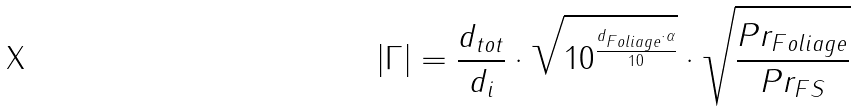Convert formula to latex. <formula><loc_0><loc_0><loc_500><loc_500>| \Gamma | = \frac { d _ { t o t } } { d _ { i } } \cdot \sqrt { 1 0 ^ { \frac { d _ { F o l i a g e } \cdot \alpha } { 1 0 } } } \cdot \sqrt { \frac { P r _ { F o l i a g e } } { P r _ { F S } } }</formula> 